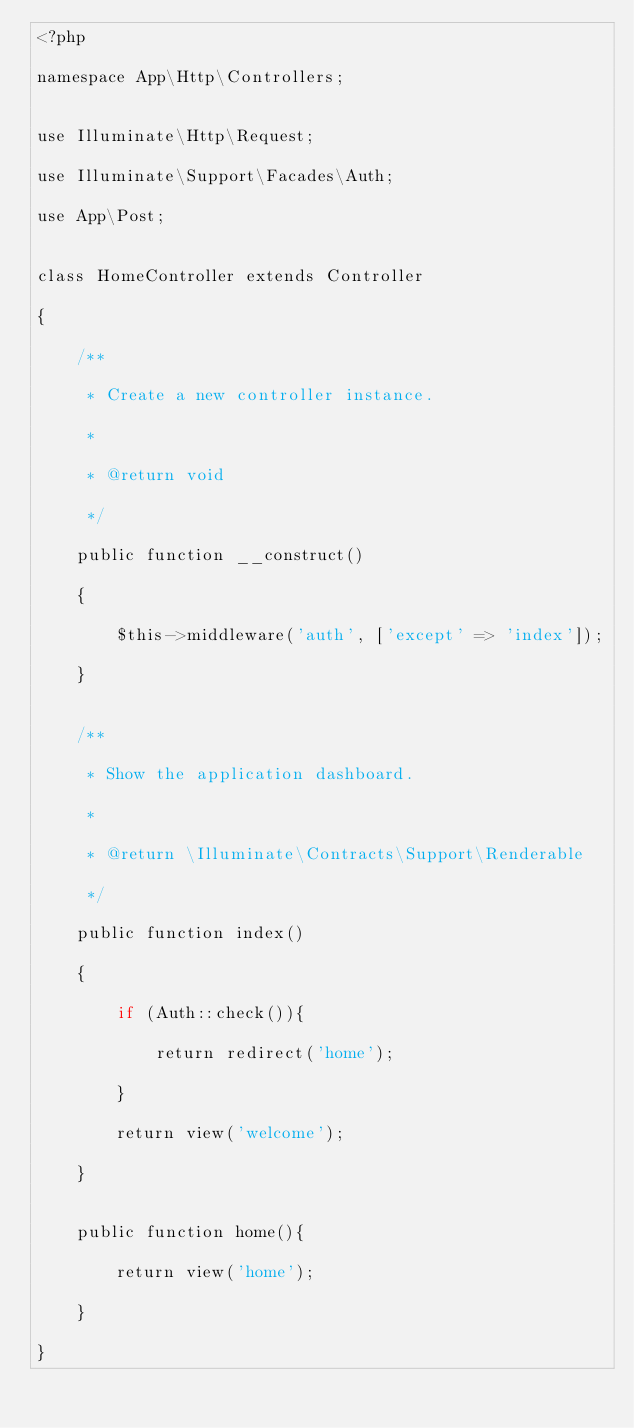<code> <loc_0><loc_0><loc_500><loc_500><_PHP_><?php

namespace App\Http\Controllers;


use Illuminate\Http\Request;

use Illuminate\Support\Facades\Auth;

use App\Post;


class HomeController extends Controller

{

    /**

     * Create a new controller instance.

     *

     * @return void

     */

    public function __construct()

    {

        $this->middleware('auth', ['except' => 'index']);

    }


    /**

     * Show the application dashboard.

     *

     * @return \Illuminate\Contracts\Support\Renderable

     */

    public function index()

    {  

        if (Auth::check()){            

            return redirect('home');

        }

        return view('welcome');        

    }


    public function home(){

        return view('home');

    }

}</code> 